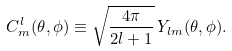Convert formula to latex. <formula><loc_0><loc_0><loc_500><loc_500>C ^ { l } _ { m } ( \theta , \phi ) \equiv \sqrt { \frac { 4 \pi } { 2 l + 1 } } \, Y _ { l m } ( \theta , \phi ) .</formula> 